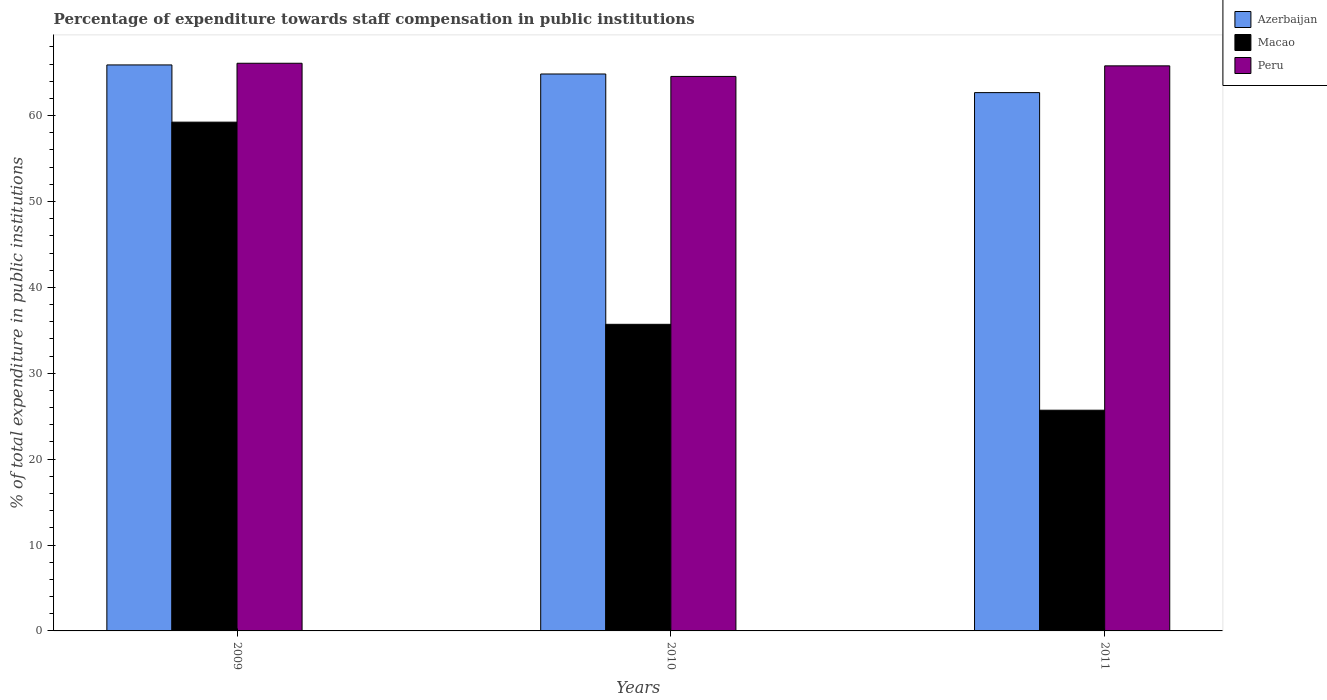How many groups of bars are there?
Your answer should be compact. 3. Are the number of bars per tick equal to the number of legend labels?
Provide a short and direct response. Yes. Are the number of bars on each tick of the X-axis equal?
Keep it short and to the point. Yes. How many bars are there on the 3rd tick from the right?
Give a very brief answer. 3. What is the label of the 3rd group of bars from the left?
Your answer should be very brief. 2011. In how many cases, is the number of bars for a given year not equal to the number of legend labels?
Your answer should be very brief. 0. What is the percentage of expenditure towards staff compensation in Macao in 2009?
Your response must be concise. 59.24. Across all years, what is the maximum percentage of expenditure towards staff compensation in Azerbaijan?
Your answer should be compact. 65.9. Across all years, what is the minimum percentage of expenditure towards staff compensation in Peru?
Your response must be concise. 64.57. In which year was the percentage of expenditure towards staff compensation in Azerbaijan maximum?
Offer a very short reply. 2009. In which year was the percentage of expenditure towards staff compensation in Peru minimum?
Provide a succinct answer. 2010. What is the total percentage of expenditure towards staff compensation in Peru in the graph?
Make the answer very short. 196.46. What is the difference between the percentage of expenditure towards staff compensation in Peru in 2009 and that in 2011?
Your answer should be very brief. 0.3. What is the difference between the percentage of expenditure towards staff compensation in Peru in 2011 and the percentage of expenditure towards staff compensation in Azerbaijan in 2010?
Make the answer very short. 0.95. What is the average percentage of expenditure towards staff compensation in Macao per year?
Provide a succinct answer. 40.21. In the year 2011, what is the difference between the percentage of expenditure towards staff compensation in Macao and percentage of expenditure towards staff compensation in Azerbaijan?
Keep it short and to the point. -36.98. In how many years, is the percentage of expenditure towards staff compensation in Macao greater than 56 %?
Provide a short and direct response. 1. What is the ratio of the percentage of expenditure towards staff compensation in Azerbaijan in 2010 to that in 2011?
Offer a very short reply. 1.03. Is the percentage of expenditure towards staff compensation in Azerbaijan in 2010 less than that in 2011?
Offer a very short reply. No. Is the difference between the percentage of expenditure towards staff compensation in Macao in 2009 and 2011 greater than the difference between the percentage of expenditure towards staff compensation in Azerbaijan in 2009 and 2011?
Keep it short and to the point. Yes. What is the difference between the highest and the second highest percentage of expenditure towards staff compensation in Peru?
Offer a terse response. 0.3. What is the difference between the highest and the lowest percentage of expenditure towards staff compensation in Peru?
Offer a terse response. 1.53. Is the sum of the percentage of expenditure towards staff compensation in Azerbaijan in 2009 and 2010 greater than the maximum percentage of expenditure towards staff compensation in Peru across all years?
Your response must be concise. Yes. What does the 1st bar from the left in 2010 represents?
Make the answer very short. Azerbaijan. What does the 2nd bar from the right in 2011 represents?
Give a very brief answer. Macao. Is it the case that in every year, the sum of the percentage of expenditure towards staff compensation in Peru and percentage of expenditure towards staff compensation in Azerbaijan is greater than the percentage of expenditure towards staff compensation in Macao?
Provide a succinct answer. Yes. How many bars are there?
Give a very brief answer. 9. Are all the bars in the graph horizontal?
Make the answer very short. No. How many years are there in the graph?
Ensure brevity in your answer.  3. Are the values on the major ticks of Y-axis written in scientific E-notation?
Provide a short and direct response. No. Does the graph contain grids?
Your response must be concise. No. How many legend labels are there?
Give a very brief answer. 3. How are the legend labels stacked?
Your answer should be compact. Vertical. What is the title of the graph?
Your response must be concise. Percentage of expenditure towards staff compensation in public institutions. Does "Germany" appear as one of the legend labels in the graph?
Your response must be concise. No. What is the label or title of the X-axis?
Offer a very short reply. Years. What is the label or title of the Y-axis?
Ensure brevity in your answer.  % of total expenditure in public institutions. What is the % of total expenditure in public institutions of Azerbaijan in 2009?
Give a very brief answer. 65.9. What is the % of total expenditure in public institutions of Macao in 2009?
Provide a short and direct response. 59.24. What is the % of total expenditure in public institutions of Peru in 2009?
Provide a succinct answer. 66.1. What is the % of total expenditure in public institutions of Azerbaijan in 2010?
Ensure brevity in your answer.  64.85. What is the % of total expenditure in public institutions in Macao in 2010?
Your response must be concise. 35.7. What is the % of total expenditure in public institutions in Peru in 2010?
Offer a terse response. 64.57. What is the % of total expenditure in public institutions of Azerbaijan in 2011?
Give a very brief answer. 62.68. What is the % of total expenditure in public institutions of Macao in 2011?
Make the answer very short. 25.7. What is the % of total expenditure in public institutions of Peru in 2011?
Provide a succinct answer. 65.8. Across all years, what is the maximum % of total expenditure in public institutions in Azerbaijan?
Offer a terse response. 65.9. Across all years, what is the maximum % of total expenditure in public institutions of Macao?
Your answer should be very brief. 59.24. Across all years, what is the maximum % of total expenditure in public institutions in Peru?
Provide a succinct answer. 66.1. Across all years, what is the minimum % of total expenditure in public institutions of Azerbaijan?
Offer a terse response. 62.68. Across all years, what is the minimum % of total expenditure in public institutions of Macao?
Ensure brevity in your answer.  25.7. Across all years, what is the minimum % of total expenditure in public institutions in Peru?
Offer a very short reply. 64.57. What is the total % of total expenditure in public institutions of Azerbaijan in the graph?
Your answer should be compact. 193.43. What is the total % of total expenditure in public institutions of Macao in the graph?
Your response must be concise. 120.64. What is the total % of total expenditure in public institutions of Peru in the graph?
Offer a terse response. 196.46. What is the difference between the % of total expenditure in public institutions in Azerbaijan in 2009 and that in 2010?
Offer a very short reply. 1.06. What is the difference between the % of total expenditure in public institutions in Macao in 2009 and that in 2010?
Your answer should be very brief. 23.54. What is the difference between the % of total expenditure in public institutions of Peru in 2009 and that in 2010?
Provide a short and direct response. 1.53. What is the difference between the % of total expenditure in public institutions in Azerbaijan in 2009 and that in 2011?
Provide a short and direct response. 3.22. What is the difference between the % of total expenditure in public institutions in Macao in 2009 and that in 2011?
Ensure brevity in your answer.  33.54. What is the difference between the % of total expenditure in public institutions of Peru in 2009 and that in 2011?
Keep it short and to the point. 0.3. What is the difference between the % of total expenditure in public institutions of Azerbaijan in 2010 and that in 2011?
Your response must be concise. 2.17. What is the difference between the % of total expenditure in public institutions in Macao in 2010 and that in 2011?
Your response must be concise. 10. What is the difference between the % of total expenditure in public institutions of Peru in 2010 and that in 2011?
Your answer should be compact. -1.23. What is the difference between the % of total expenditure in public institutions in Azerbaijan in 2009 and the % of total expenditure in public institutions in Macao in 2010?
Ensure brevity in your answer.  30.2. What is the difference between the % of total expenditure in public institutions of Azerbaijan in 2009 and the % of total expenditure in public institutions of Peru in 2010?
Your response must be concise. 1.34. What is the difference between the % of total expenditure in public institutions of Macao in 2009 and the % of total expenditure in public institutions of Peru in 2010?
Keep it short and to the point. -5.32. What is the difference between the % of total expenditure in public institutions of Azerbaijan in 2009 and the % of total expenditure in public institutions of Macao in 2011?
Provide a short and direct response. 40.2. What is the difference between the % of total expenditure in public institutions of Azerbaijan in 2009 and the % of total expenditure in public institutions of Peru in 2011?
Keep it short and to the point. 0.11. What is the difference between the % of total expenditure in public institutions in Macao in 2009 and the % of total expenditure in public institutions in Peru in 2011?
Your answer should be very brief. -6.55. What is the difference between the % of total expenditure in public institutions in Azerbaijan in 2010 and the % of total expenditure in public institutions in Macao in 2011?
Your response must be concise. 39.15. What is the difference between the % of total expenditure in public institutions in Azerbaijan in 2010 and the % of total expenditure in public institutions in Peru in 2011?
Give a very brief answer. -0.95. What is the difference between the % of total expenditure in public institutions of Macao in 2010 and the % of total expenditure in public institutions of Peru in 2011?
Keep it short and to the point. -30.1. What is the average % of total expenditure in public institutions of Azerbaijan per year?
Offer a terse response. 64.48. What is the average % of total expenditure in public institutions in Macao per year?
Provide a short and direct response. 40.21. What is the average % of total expenditure in public institutions in Peru per year?
Your response must be concise. 65.49. In the year 2009, what is the difference between the % of total expenditure in public institutions in Azerbaijan and % of total expenditure in public institutions in Macao?
Your response must be concise. 6.66. In the year 2009, what is the difference between the % of total expenditure in public institutions of Azerbaijan and % of total expenditure in public institutions of Peru?
Offer a terse response. -0.19. In the year 2009, what is the difference between the % of total expenditure in public institutions in Macao and % of total expenditure in public institutions in Peru?
Your response must be concise. -6.86. In the year 2010, what is the difference between the % of total expenditure in public institutions in Azerbaijan and % of total expenditure in public institutions in Macao?
Offer a very short reply. 29.15. In the year 2010, what is the difference between the % of total expenditure in public institutions of Azerbaijan and % of total expenditure in public institutions of Peru?
Keep it short and to the point. 0.28. In the year 2010, what is the difference between the % of total expenditure in public institutions in Macao and % of total expenditure in public institutions in Peru?
Give a very brief answer. -28.86. In the year 2011, what is the difference between the % of total expenditure in public institutions in Azerbaijan and % of total expenditure in public institutions in Macao?
Provide a succinct answer. 36.98. In the year 2011, what is the difference between the % of total expenditure in public institutions of Azerbaijan and % of total expenditure in public institutions of Peru?
Your answer should be compact. -3.12. In the year 2011, what is the difference between the % of total expenditure in public institutions in Macao and % of total expenditure in public institutions in Peru?
Offer a very short reply. -40.1. What is the ratio of the % of total expenditure in public institutions of Azerbaijan in 2009 to that in 2010?
Give a very brief answer. 1.02. What is the ratio of the % of total expenditure in public institutions in Macao in 2009 to that in 2010?
Provide a short and direct response. 1.66. What is the ratio of the % of total expenditure in public institutions of Peru in 2009 to that in 2010?
Your response must be concise. 1.02. What is the ratio of the % of total expenditure in public institutions in Azerbaijan in 2009 to that in 2011?
Ensure brevity in your answer.  1.05. What is the ratio of the % of total expenditure in public institutions in Macao in 2009 to that in 2011?
Provide a succinct answer. 2.31. What is the ratio of the % of total expenditure in public institutions of Azerbaijan in 2010 to that in 2011?
Your answer should be compact. 1.03. What is the ratio of the % of total expenditure in public institutions of Macao in 2010 to that in 2011?
Ensure brevity in your answer.  1.39. What is the ratio of the % of total expenditure in public institutions of Peru in 2010 to that in 2011?
Provide a short and direct response. 0.98. What is the difference between the highest and the second highest % of total expenditure in public institutions of Azerbaijan?
Offer a terse response. 1.06. What is the difference between the highest and the second highest % of total expenditure in public institutions in Macao?
Your answer should be very brief. 23.54. What is the difference between the highest and the second highest % of total expenditure in public institutions in Peru?
Provide a succinct answer. 0.3. What is the difference between the highest and the lowest % of total expenditure in public institutions of Azerbaijan?
Provide a succinct answer. 3.22. What is the difference between the highest and the lowest % of total expenditure in public institutions in Macao?
Give a very brief answer. 33.54. What is the difference between the highest and the lowest % of total expenditure in public institutions in Peru?
Make the answer very short. 1.53. 